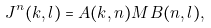<formula> <loc_0><loc_0><loc_500><loc_500>J ^ { n } ( k , l ) = A ( k , n ) M B ( n , l ) ,</formula> 